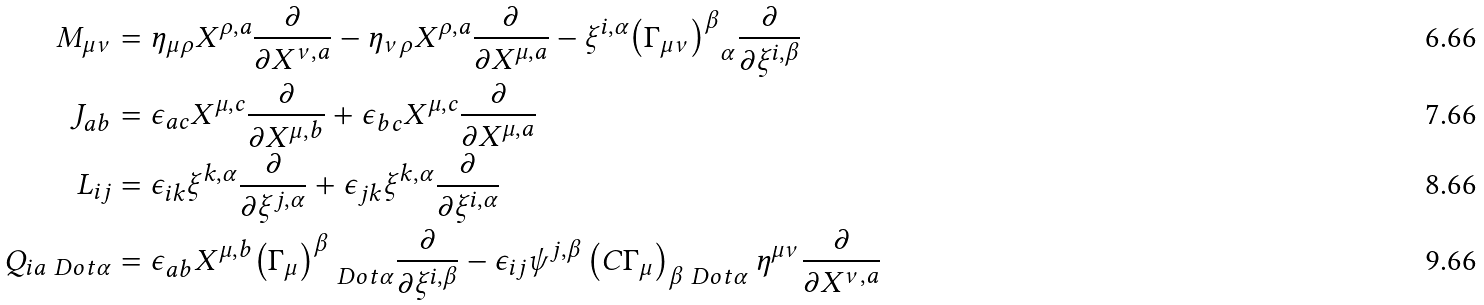Convert formula to latex. <formula><loc_0><loc_0><loc_500><loc_500>M _ { \mu \nu } & = \eta _ { \mu \rho } X ^ { \rho , a } \frac { \partial } { \partial X ^ { \nu , a } } - \eta _ { \nu \rho } X ^ { \rho , a } \frac { \partial } { \partial X ^ { \mu , a } } - \xi ^ { i , \alpha } { \left ( \Gamma _ { \mu \nu } \right ) ^ { \beta } } _ { \alpha } \frac { \partial } { \partial \xi ^ { i , \beta } } \\ J _ { a b } & = \epsilon _ { a c } X ^ { \mu , c } \frac { \partial } { \partial X ^ { \mu , b } } + \epsilon _ { b c } X ^ { \mu , c } \frac { \partial } { \partial X ^ { \mu , a } } \\ L _ { i j } & = \epsilon _ { i k } \xi ^ { k , \alpha } \frac { \partial } { \partial \xi ^ { j , \alpha } } + \epsilon _ { j k } \xi ^ { k , \alpha } \frac { \partial } { \partial \xi ^ { i , \alpha } } \\ Q _ { i a \ D o t { \alpha } } & = \epsilon _ { a b } X ^ { \mu , b } { \left ( \Gamma _ { \mu } \right ) ^ { \beta } } _ { \ D o t { \alpha } } \frac { \partial } { \partial \xi ^ { i , \beta } } - \epsilon _ { i j } \psi ^ { j , \beta } \left ( C \Gamma _ { \mu } \right ) _ { \beta \ D o t { \alpha } } \eta ^ { \mu \nu } \frac { \partial } { \partial X ^ { \nu , a } }</formula> 